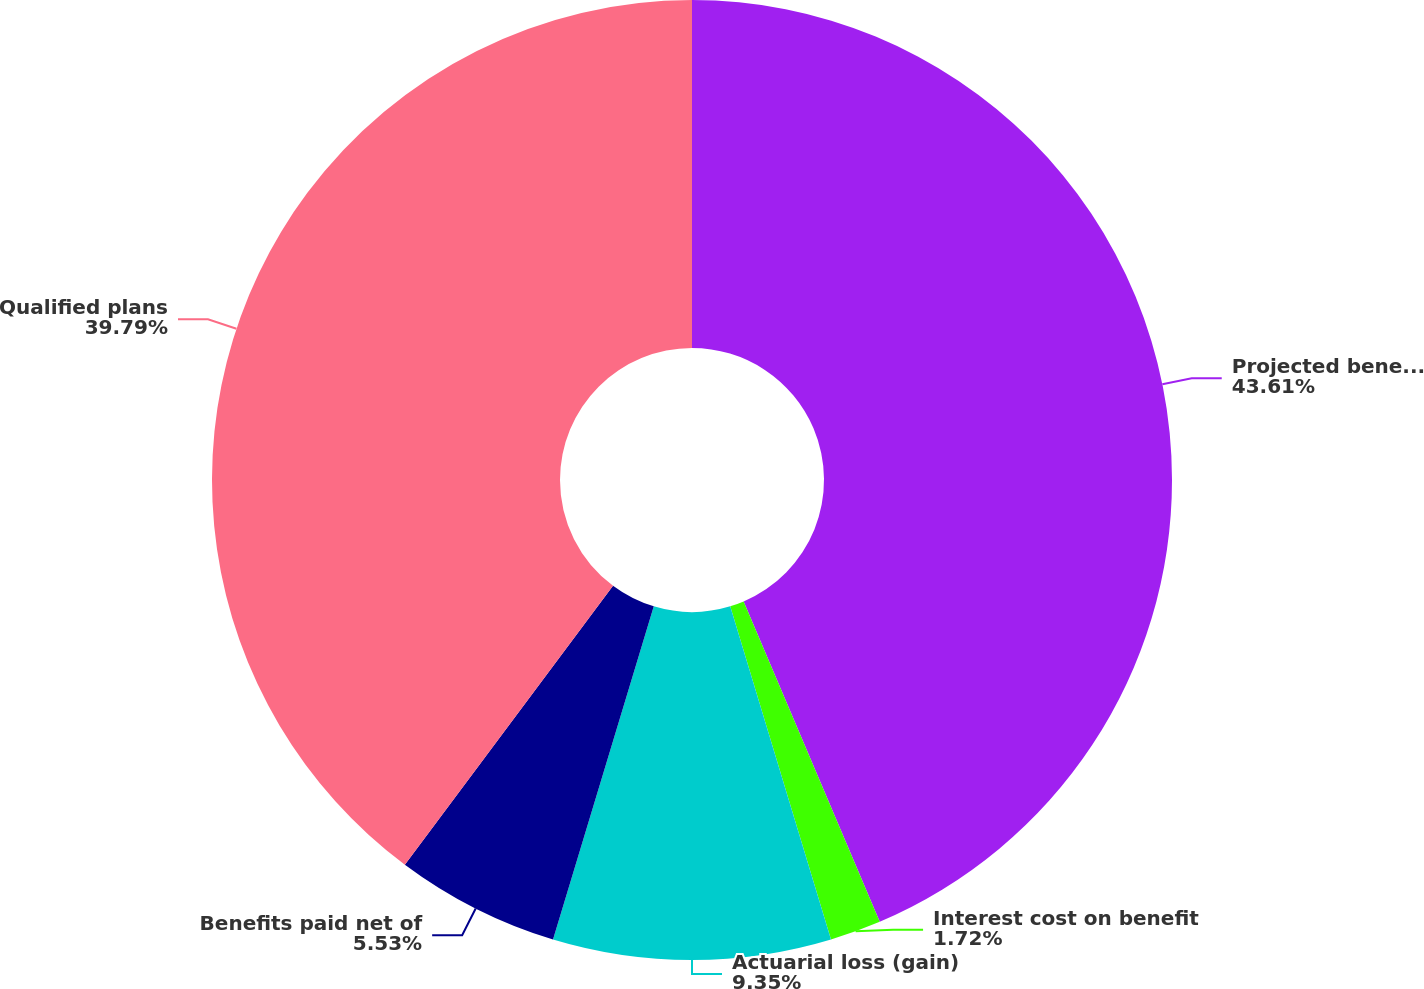Convert chart. <chart><loc_0><loc_0><loc_500><loc_500><pie_chart><fcel>Projected benefit obligation<fcel>Interest cost on benefit<fcel>Actuarial loss (gain)<fcel>Benefits paid net of<fcel>Qualified plans<nl><fcel>43.6%<fcel>1.72%<fcel>9.35%<fcel>5.53%<fcel>39.79%<nl></chart> 